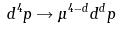<formula> <loc_0><loc_0><loc_500><loc_500>d ^ { 4 } p \rightarrow \mu ^ { 4 - d } d ^ { d } p</formula> 